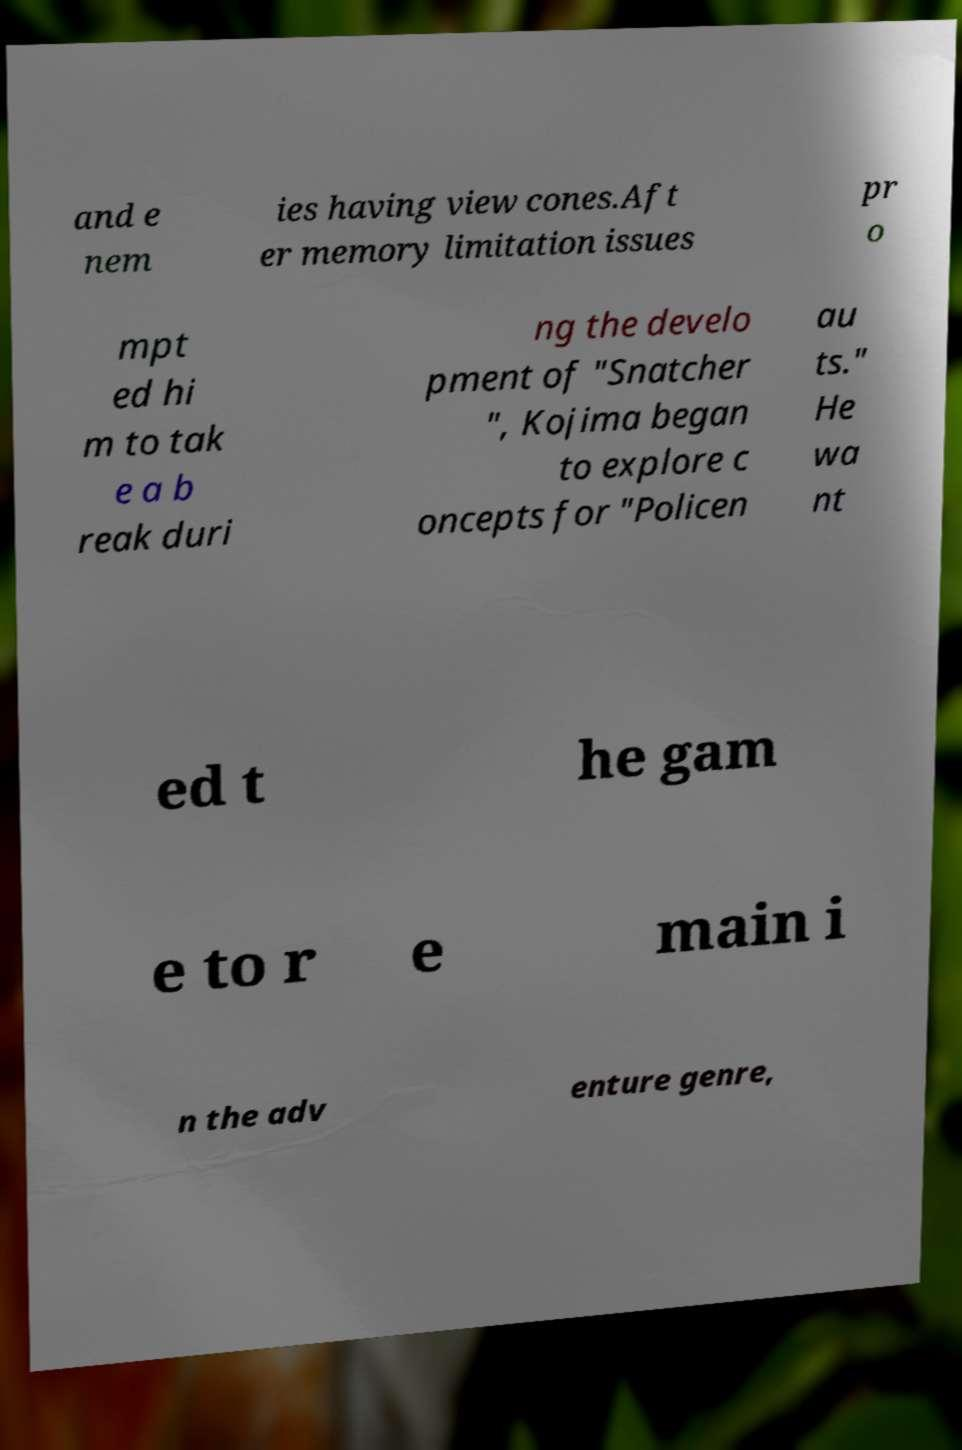Could you extract and type out the text from this image? and e nem ies having view cones.Aft er memory limitation issues pr o mpt ed hi m to tak e a b reak duri ng the develo pment of "Snatcher ", Kojima began to explore c oncepts for "Policen au ts." He wa nt ed t he gam e to r e main i n the adv enture genre, 